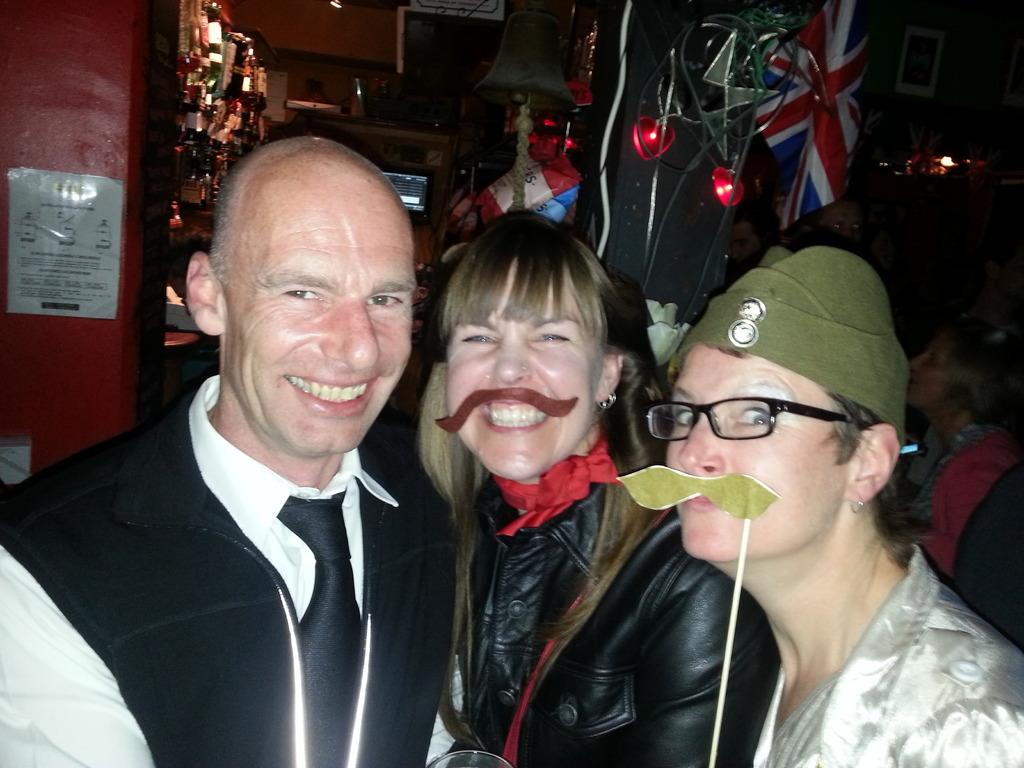What can be seen in the image involving people? There are people standing in the image. What else is present in the image besides people? There are objects in the image. Where is the flag located in the image? The flag is on the right side of the image. What other specific object can be seen in the image? There is a bell in the image. Can you tell me how the goat is stretching in the image? There is no goat present in the image, so it cannot be determined how a goat might be stretching. 